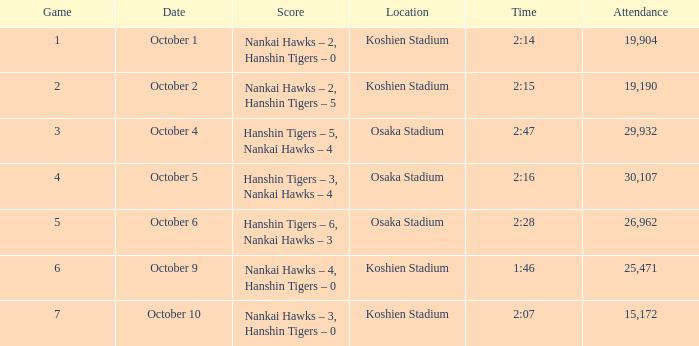Which Score has a Time of 2:28? Hanshin Tigers – 6, Nankai Hawks – 3. 